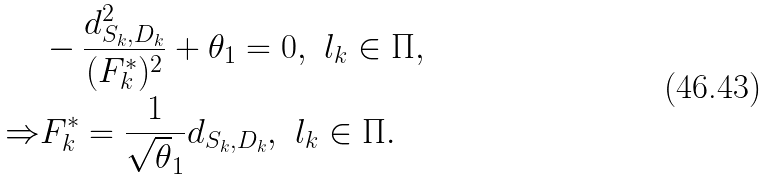<formula> <loc_0><loc_0><loc_500><loc_500>& - \frac { d _ { S _ { k } , D _ { k } } ^ { 2 } } { ( F _ { k } ^ { * } ) ^ { 2 } } + \theta _ { 1 } = 0 , \ l _ { k } \in \Pi , \\ \Rightarrow & F _ { k } ^ { * } = \frac { 1 } { \sqrt { \theta } _ { 1 } } d _ { S _ { k } , D _ { k } } , \ l _ { k } \in \Pi .</formula> 